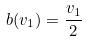<formula> <loc_0><loc_0><loc_500><loc_500>b ( v _ { 1 } ) = \frac { v _ { 1 } } { 2 }</formula> 